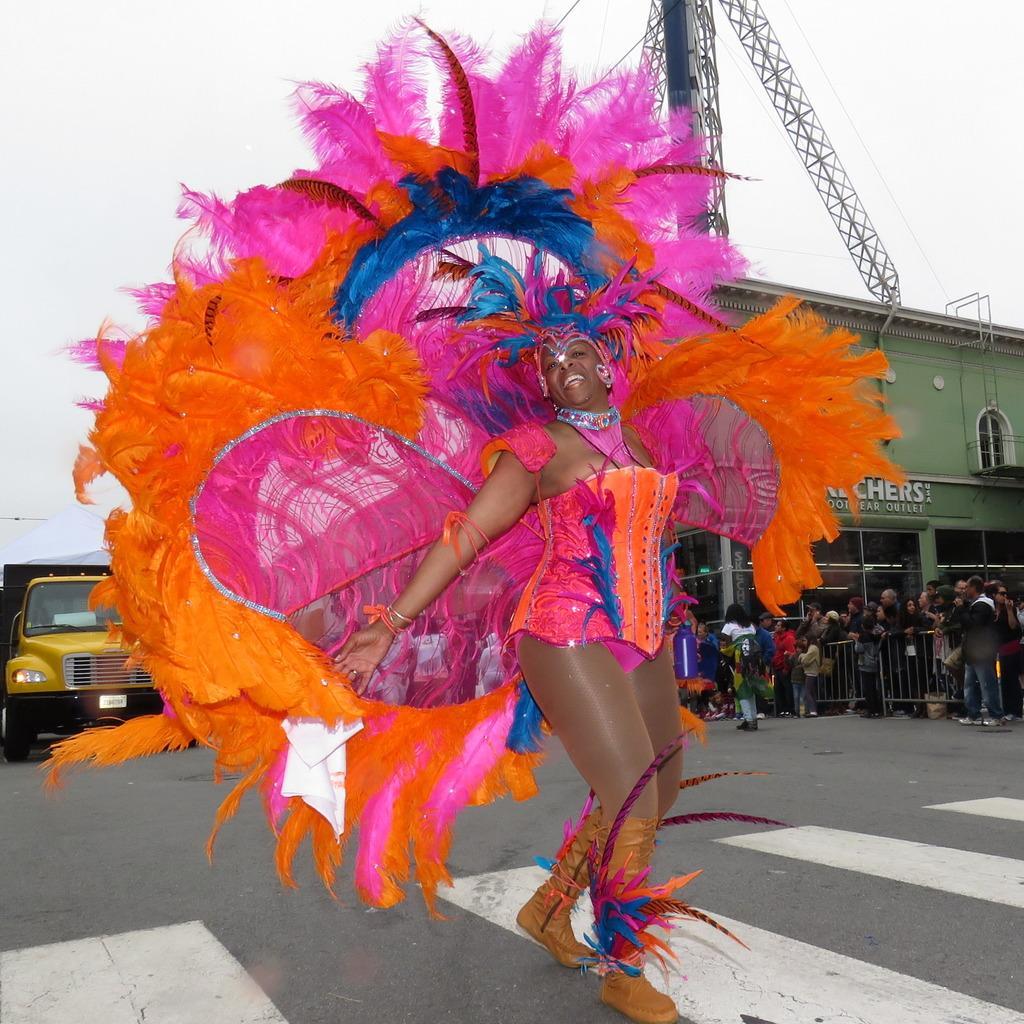Could you give a brief overview of what you see in this image? In this image there is a woman walking with a smile on her face, behind the woman there is a truck and there are people standing in a queue in front of a building. 